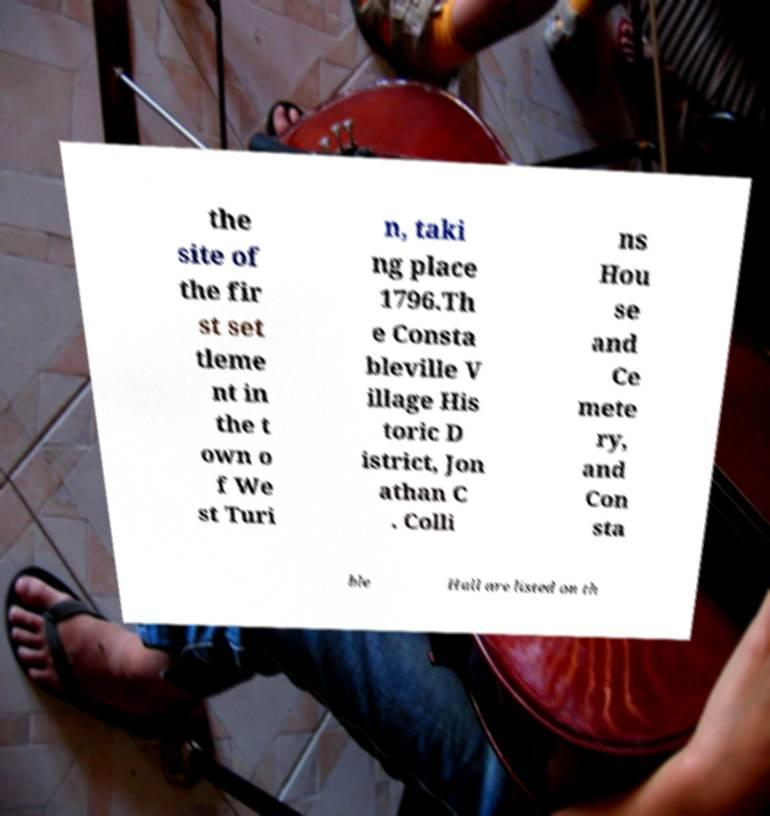Can you accurately transcribe the text from the provided image for me? the site of the fir st set tleme nt in the t own o f We st Turi n, taki ng place 1796.Th e Consta bleville V illage His toric D istrict, Jon athan C . Colli ns Hou se and Ce mete ry, and Con sta ble Hall are listed on th 